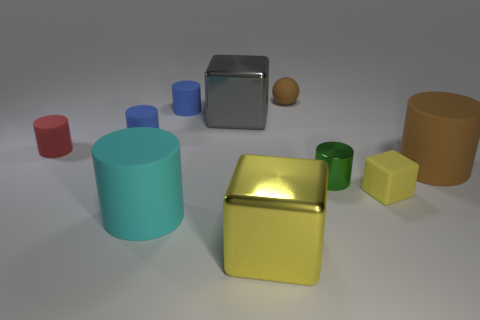Subtract all purple balls. How many yellow blocks are left? 2 Subtract all small red rubber cylinders. How many cylinders are left? 5 Subtract all cyan cylinders. How many cylinders are left? 5 Subtract all red cylinders. Subtract all purple cubes. How many cylinders are left? 5 Subtract all cylinders. How many objects are left? 4 Subtract 1 brown spheres. How many objects are left? 9 Subtract all big gray things. Subtract all matte cylinders. How many objects are left? 4 Add 8 tiny red cylinders. How many tiny red cylinders are left? 9 Add 2 cylinders. How many cylinders exist? 8 